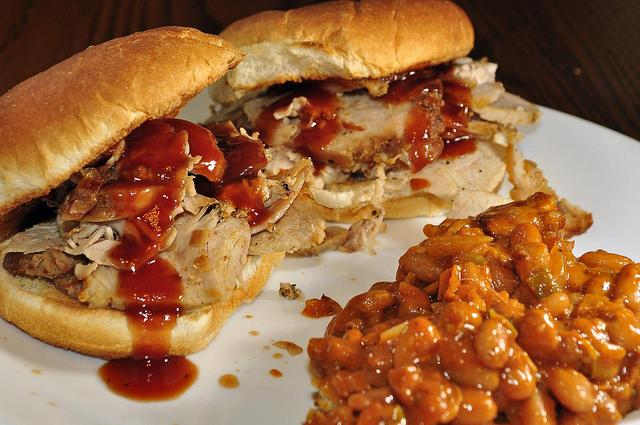What is the original color of the baked beans in the dish?

Choices:
A) brown
B) gray
C) white
D) black white 